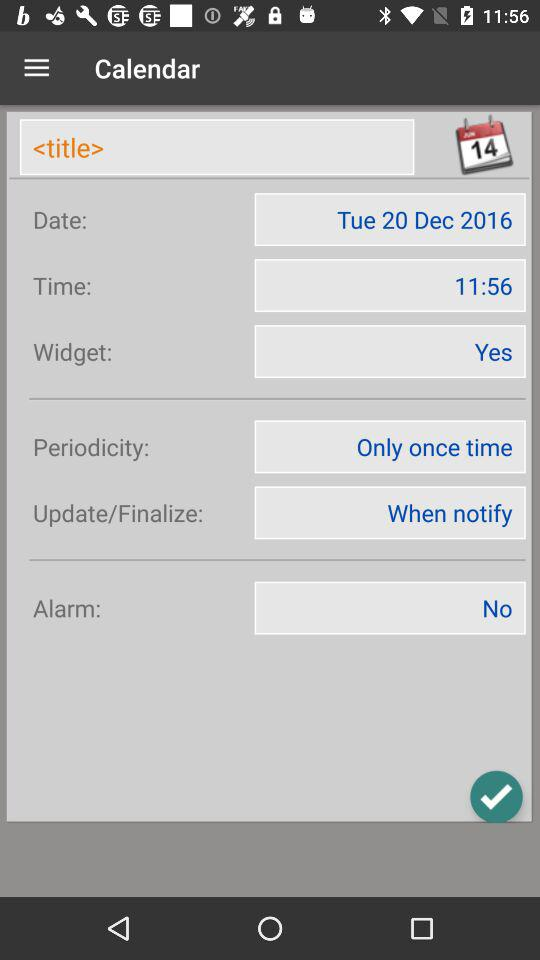What's the periodicity? The periodicity is "Only once time". 